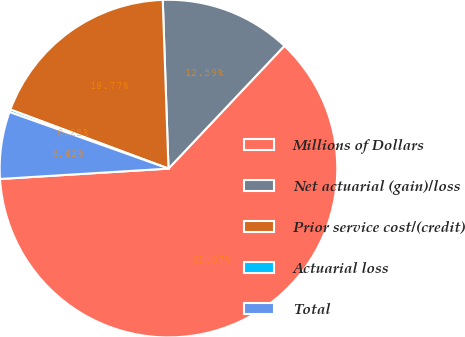Convert chart to OTSL. <chart><loc_0><loc_0><loc_500><loc_500><pie_chart><fcel>Millions of Dollars<fcel>Net actuarial (gain)/loss<fcel>Prior service cost/(credit)<fcel>Actuarial loss<fcel>Total<nl><fcel>61.98%<fcel>12.59%<fcel>18.77%<fcel>0.25%<fcel>6.42%<nl></chart> 